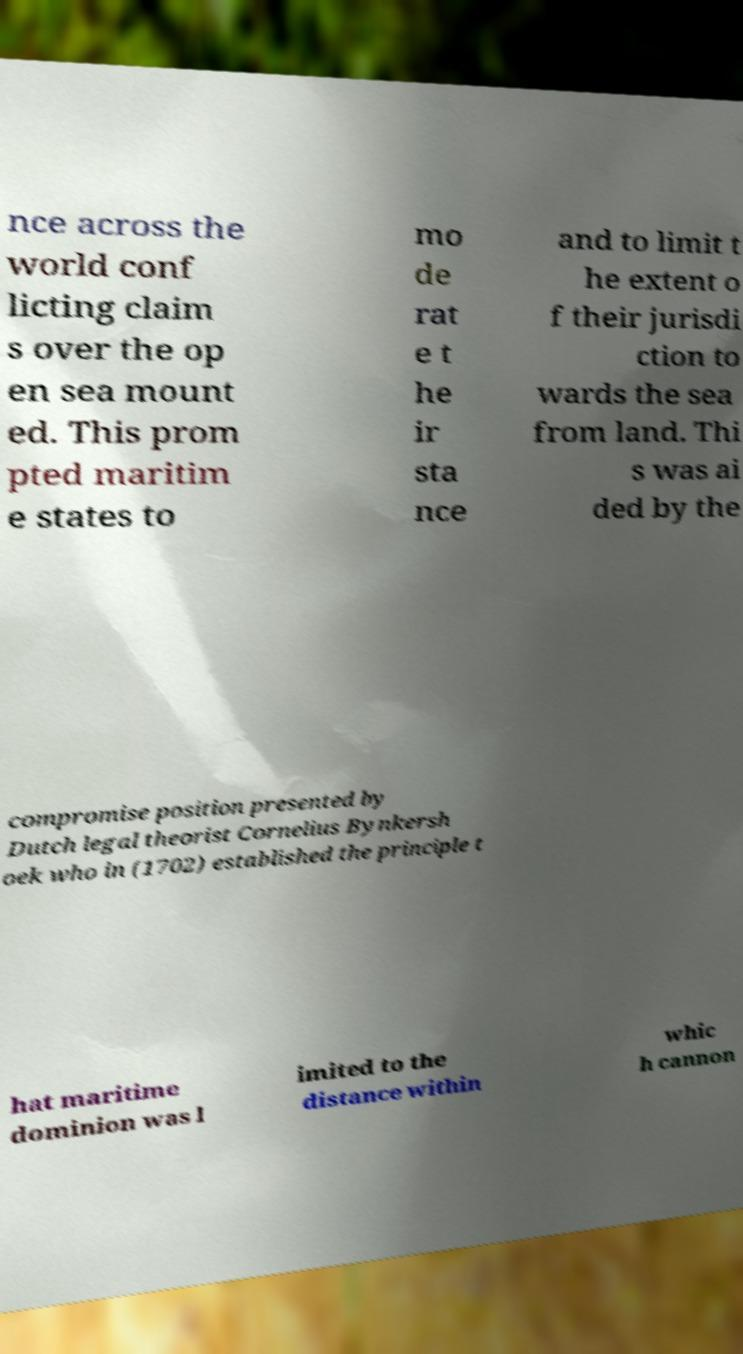There's text embedded in this image that I need extracted. Can you transcribe it verbatim? nce across the world conf licting claim s over the op en sea mount ed. This prom pted maritim e states to mo de rat e t he ir sta nce and to limit t he extent o f their jurisdi ction to wards the sea from land. Thi s was ai ded by the compromise position presented by Dutch legal theorist Cornelius Bynkersh oek who in (1702) established the principle t hat maritime dominion was l imited to the distance within whic h cannon 